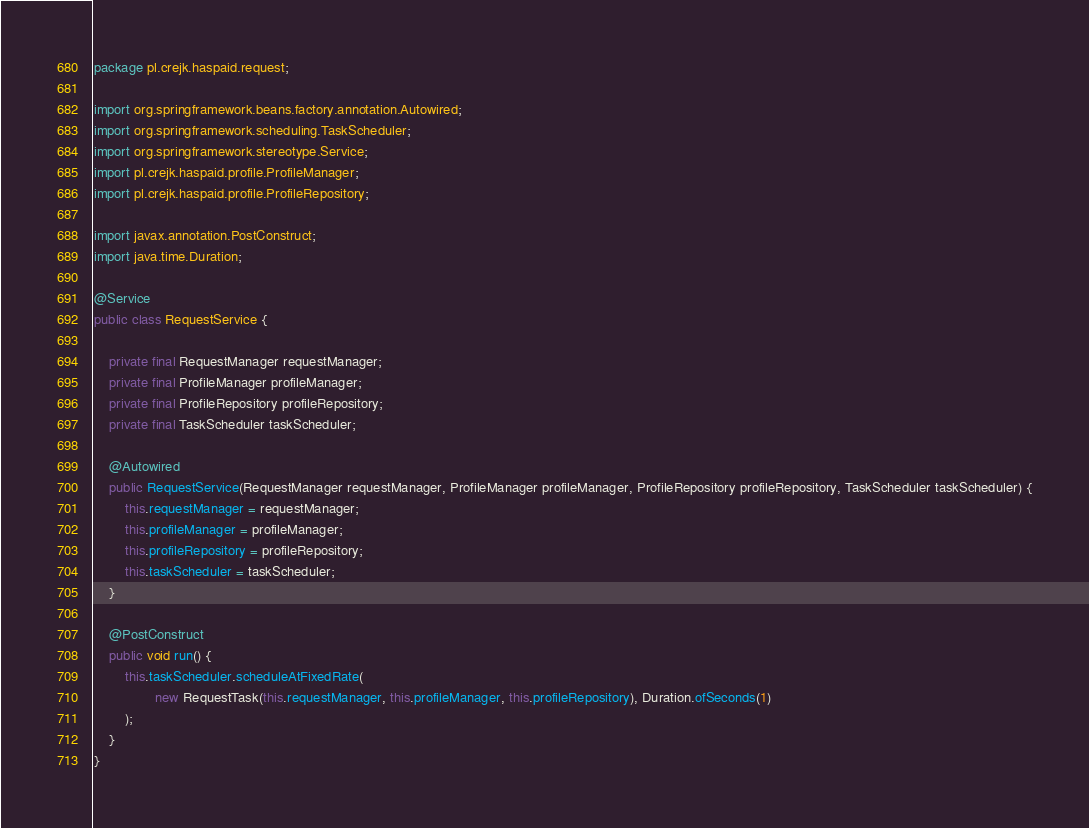Convert code to text. <code><loc_0><loc_0><loc_500><loc_500><_Java_>package pl.crejk.haspaid.request;

import org.springframework.beans.factory.annotation.Autowired;
import org.springframework.scheduling.TaskScheduler;
import org.springframework.stereotype.Service;
import pl.crejk.haspaid.profile.ProfileManager;
import pl.crejk.haspaid.profile.ProfileRepository;

import javax.annotation.PostConstruct;
import java.time.Duration;

@Service
public class RequestService {

    private final RequestManager requestManager;
    private final ProfileManager profileManager;
    private final ProfileRepository profileRepository;
    private final TaskScheduler taskScheduler;

    @Autowired
    public RequestService(RequestManager requestManager, ProfileManager profileManager, ProfileRepository profileRepository, TaskScheduler taskScheduler) {
        this.requestManager = requestManager;
        this.profileManager = profileManager;
        this.profileRepository = profileRepository;
        this.taskScheduler = taskScheduler;
    }

    @PostConstruct
    public void run() {
        this.taskScheduler.scheduleAtFixedRate(
                new RequestTask(this.requestManager, this.profileManager, this.profileRepository), Duration.ofSeconds(1)
        );
    }
}
</code> 